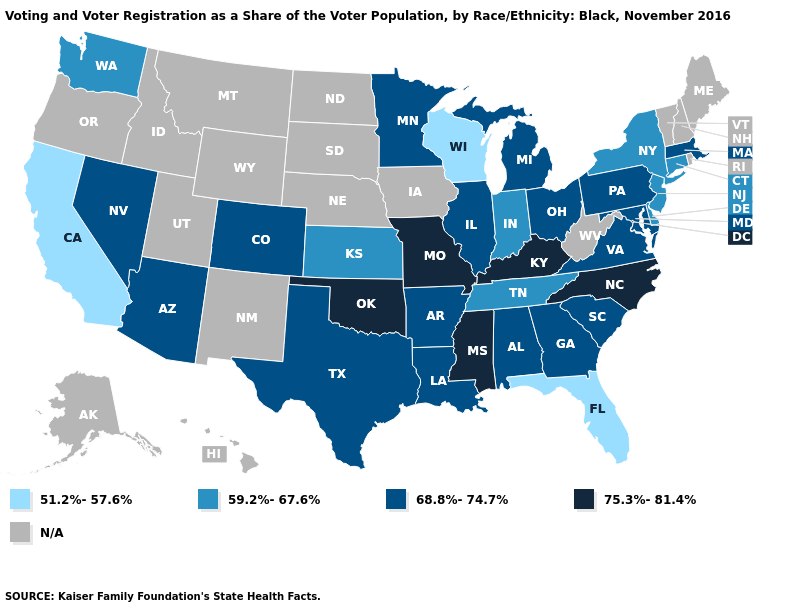Name the states that have a value in the range 68.8%-74.7%?
Be succinct. Alabama, Arizona, Arkansas, Colorado, Georgia, Illinois, Louisiana, Maryland, Massachusetts, Michigan, Minnesota, Nevada, Ohio, Pennsylvania, South Carolina, Texas, Virginia. Among the states that border Tennessee , does Virginia have the highest value?
Concise answer only. No. What is the highest value in the West ?
Keep it brief. 68.8%-74.7%. Name the states that have a value in the range 59.2%-67.6%?
Short answer required. Connecticut, Delaware, Indiana, Kansas, New Jersey, New York, Tennessee, Washington. Does the map have missing data?
Answer briefly. Yes. What is the value of North Dakota?
Give a very brief answer. N/A. Does the first symbol in the legend represent the smallest category?
Be succinct. Yes. What is the value of New Mexico?
Give a very brief answer. N/A. What is the value of Illinois?
Give a very brief answer. 68.8%-74.7%. Does the first symbol in the legend represent the smallest category?
Give a very brief answer. Yes. Name the states that have a value in the range N/A?
Answer briefly. Alaska, Hawaii, Idaho, Iowa, Maine, Montana, Nebraska, New Hampshire, New Mexico, North Dakota, Oregon, Rhode Island, South Dakota, Utah, Vermont, West Virginia, Wyoming. What is the lowest value in states that border Kansas?
Quick response, please. 68.8%-74.7%. What is the value of Florida?
Be succinct. 51.2%-57.6%. 